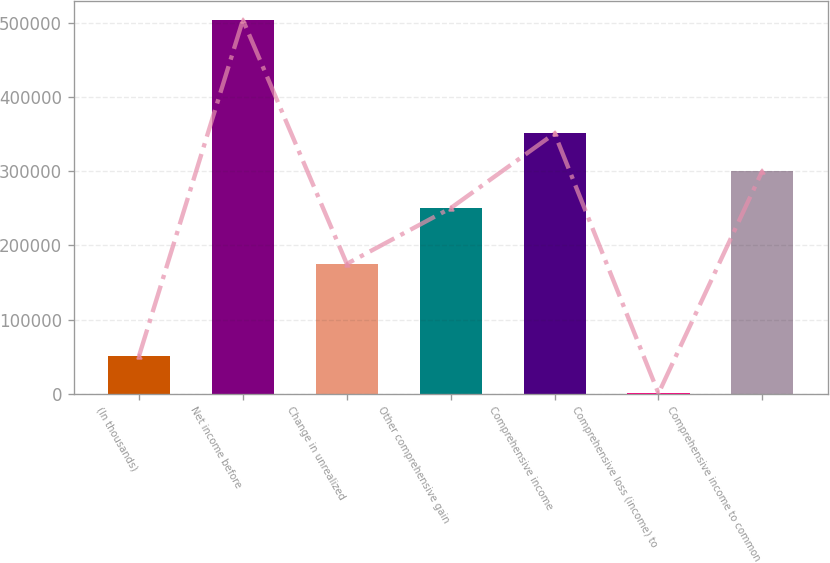Convert chart to OTSL. <chart><loc_0><loc_0><loc_500><loc_500><bar_chart><fcel>(In thousands)<fcel>Net income before<fcel>Change in unrealized<fcel>Other comprehensive gain<fcel>Comprehensive income<fcel>Comprehensive loss (income) to<fcel>Comprehensive income to common<nl><fcel>50748.2<fcel>504107<fcel>175117<fcel>250286<fcel>351032<fcel>375<fcel>300659<nl></chart> 